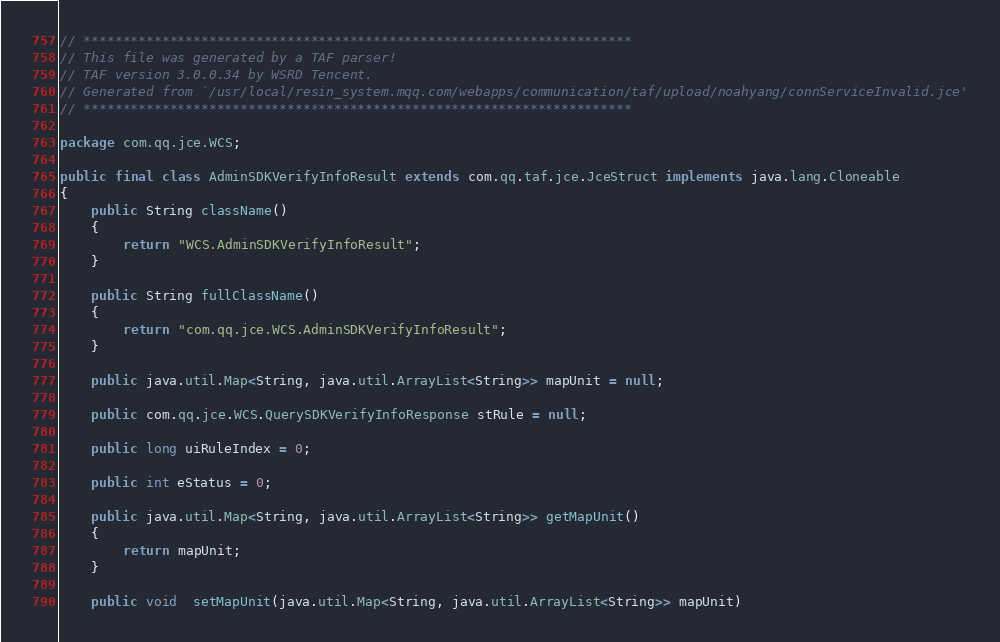<code> <loc_0><loc_0><loc_500><loc_500><_Java_>// **********************************************************************
// This file was generated by a TAF parser!
// TAF version 3.0.0.34 by WSRD Tencent.
// Generated from `/usr/local/resin_system.mqq.com/webapps/communication/taf/upload/noahyang/connServiceInvalid.jce'
// **********************************************************************

package com.qq.jce.WCS;

public final class AdminSDKVerifyInfoResult extends com.qq.taf.jce.JceStruct implements java.lang.Cloneable
{
    public String className()
    {
        return "WCS.AdminSDKVerifyInfoResult";
    }

    public String fullClassName()
    {
        return "com.qq.jce.WCS.AdminSDKVerifyInfoResult";
    }

    public java.util.Map<String, java.util.ArrayList<String>> mapUnit = null;

    public com.qq.jce.WCS.QuerySDKVerifyInfoResponse stRule = null;

    public long uiRuleIndex = 0;

    public int eStatus = 0;

    public java.util.Map<String, java.util.ArrayList<String>> getMapUnit()
    {
        return mapUnit;
    }

    public void  setMapUnit(java.util.Map<String, java.util.ArrayList<String>> mapUnit)</code> 